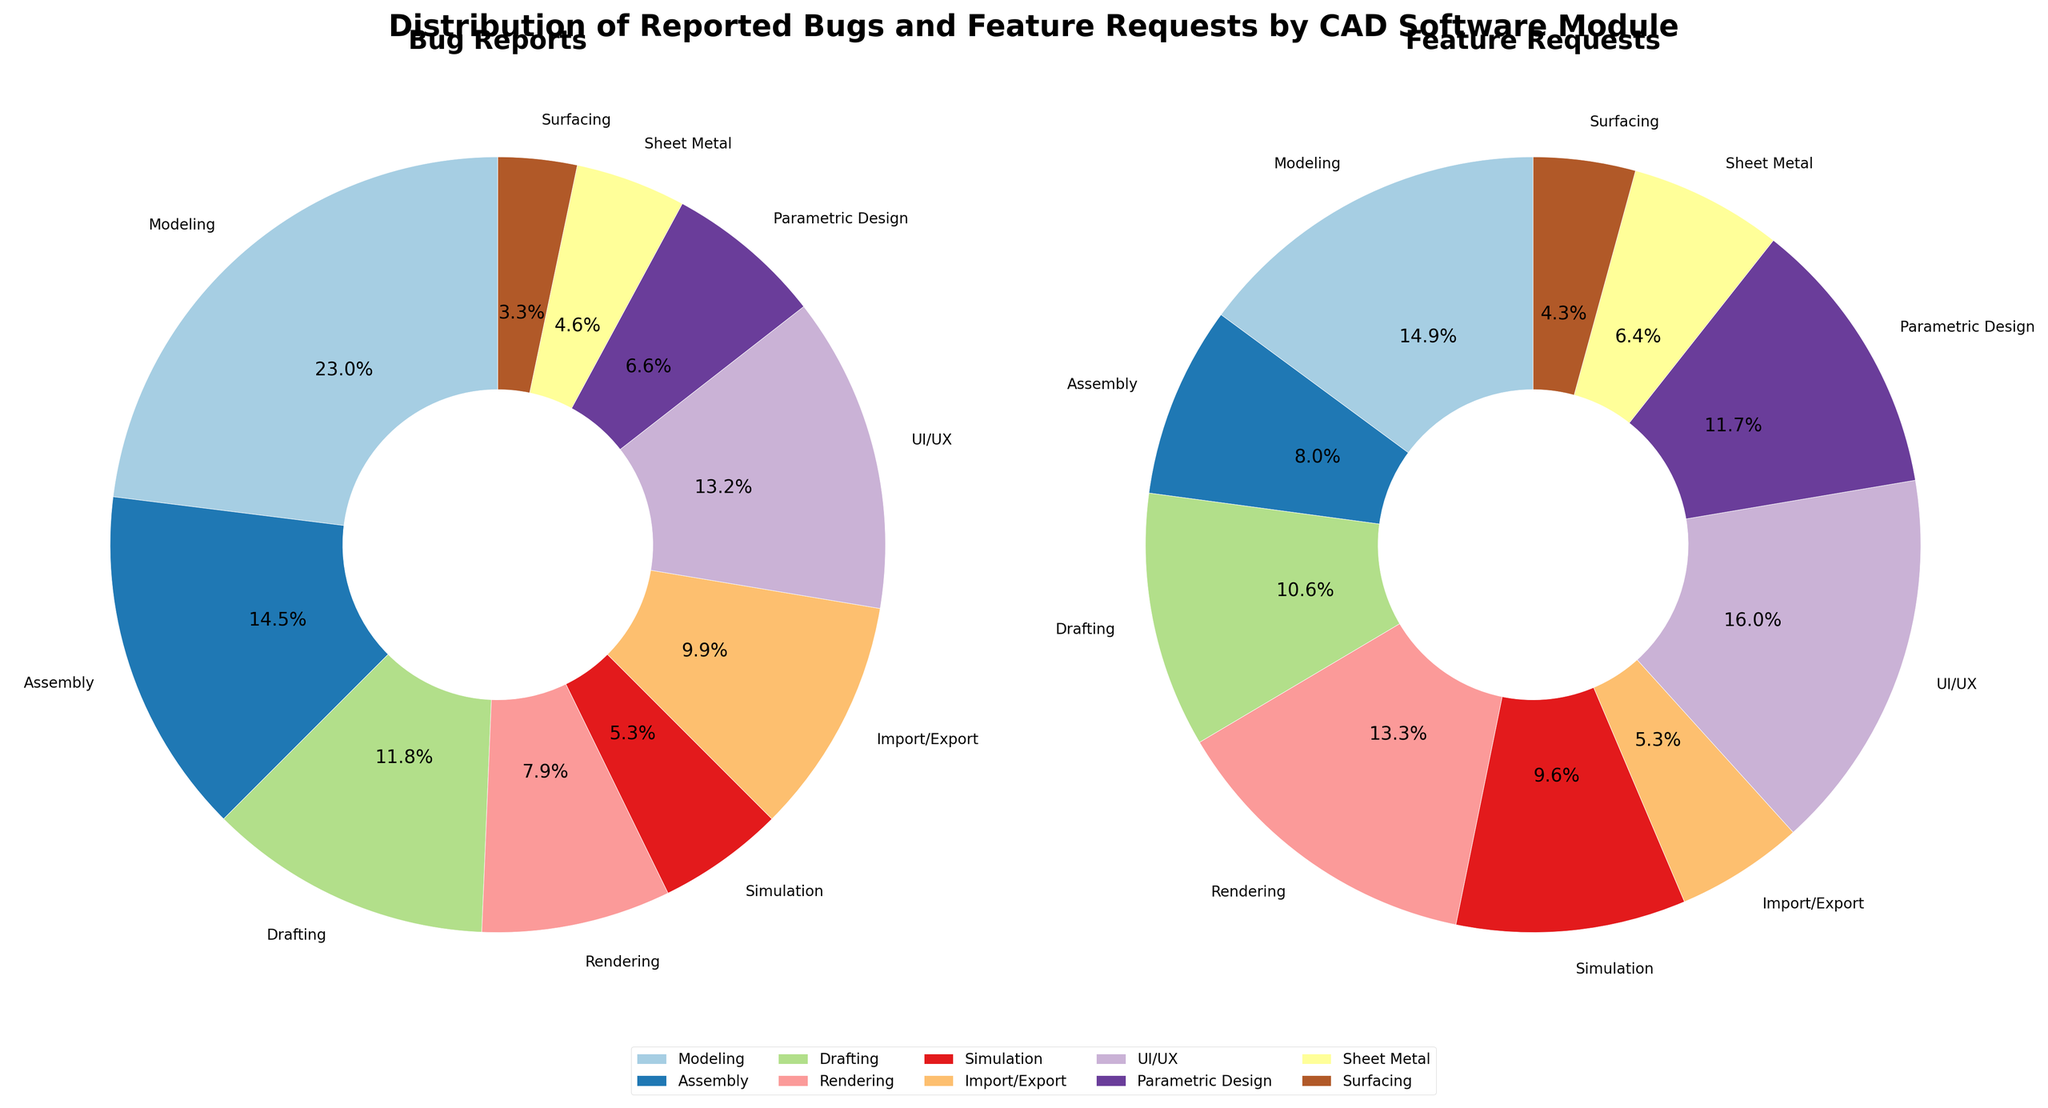Which module has the highest number of bug reports? By looking at the Bug Reports pie chart, we can tell which segment is the largest. The Modeling module has the largest segment in the Bug Reports pie chart.
Answer: Modeling Which module has the highest percentage of feature requests? By looking at the Feature Requests pie chart, we can see that the UI/UX module has the largest segment, indicating it has the highest percentage of feature requests.
Answer: UI/UX Which module has the lowest number of bug reports? By observing the Bug Reports pie chart, it is evident that the Surfacing module has the smallest segment, indicating the lowest number of bug reports.
Answer: Surfacing What is the combined total of bug reports and feature requests for the Assembly module? From the data and the pie charts, the Assembly module has 22 bug reports and 15 feature requests. Adding these together gives 22 + 15 = 37.
Answer: 37 How does the number of feature requests for the UI/UX module compare to the number of bug reports for the same module? From the data and the pie charts, the UI/UX module has 20 bug reports and 30 feature requests. 30 feature requests are higher than 20 bug reports.
Answer: Feature Requests > Bug Reports What percentage of total bug reports is contributed by the Modeling module? The Modeling module has 35 bug reports. To find the percentage, divide 35 by the total number of bug reports and multiply by 100. The total number of bug reports is 35 + 22 + 18 + 12 + 8 + 15 + 20 + 10 + 7 + 5 = 152. Therefore, (35 / 152) * 100 ≈ 23.03%.
Answer: 23.03% Which module has a larger portion of feature requests compared to its portion of bug reports? By comparing the two pie charts, we see that Rendering has a higher portion in Feature Requests compared to Bug Reports.
Answer: Rendering Calculate the difference between the total number of bugs reported for the Import/Export and Simulation modules. The data shows 15 bug reports for Import/Export and 8 for Simulation. The difference is 15 - 8 = 7.
Answer: 7 What is the ratio of feature requests to bug reports for the Drafting module? The Drafting module has 20 feature requests and 18 bug reports. The ratio is 20:18, which simplifies to 10:9.
Answer: 10:9 